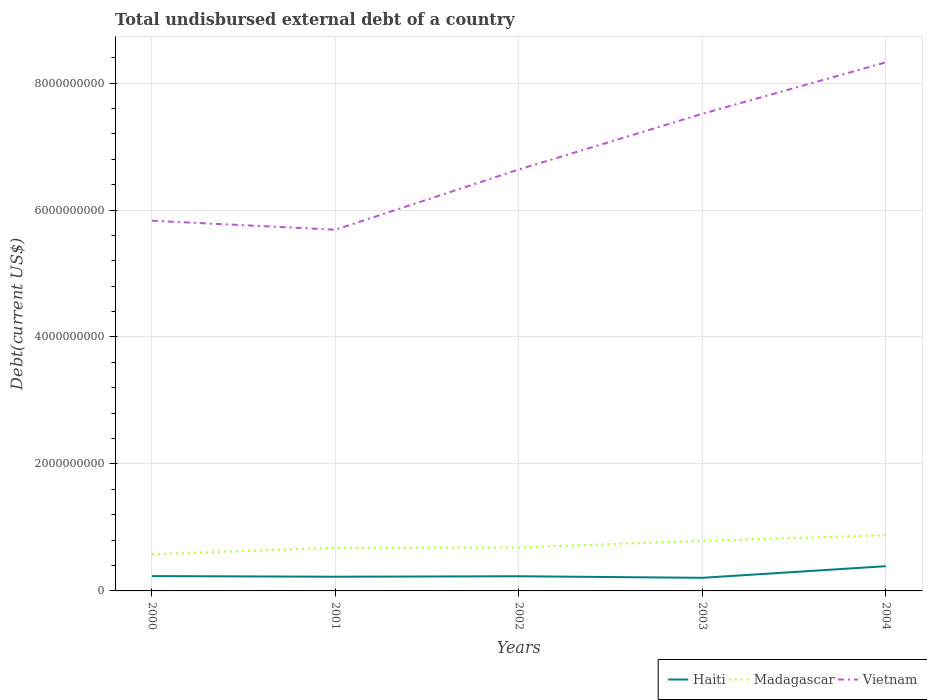Does the line corresponding to Haiti intersect with the line corresponding to Madagascar?
Your answer should be compact. No. Is the number of lines equal to the number of legend labels?
Make the answer very short. Yes. Across all years, what is the maximum total undisbursed external debt in Madagascar?
Your answer should be compact. 5.77e+08. In which year was the total undisbursed external debt in Haiti maximum?
Make the answer very short. 2003. What is the total total undisbursed external debt in Vietnam in the graph?
Offer a very short reply. -1.83e+09. What is the difference between the highest and the second highest total undisbursed external debt in Vietnam?
Ensure brevity in your answer.  2.64e+09. How many lines are there?
Give a very brief answer. 3. How many years are there in the graph?
Provide a short and direct response. 5. Does the graph contain any zero values?
Your response must be concise. No. Does the graph contain grids?
Provide a short and direct response. Yes. Where does the legend appear in the graph?
Give a very brief answer. Bottom right. How many legend labels are there?
Keep it short and to the point. 3. How are the legend labels stacked?
Provide a succinct answer. Horizontal. What is the title of the graph?
Ensure brevity in your answer.  Total undisbursed external debt of a country. What is the label or title of the Y-axis?
Offer a terse response. Debt(current US$). What is the Debt(current US$) of Haiti in 2000?
Keep it short and to the point. 2.34e+08. What is the Debt(current US$) of Madagascar in 2000?
Your response must be concise. 5.77e+08. What is the Debt(current US$) of Vietnam in 2000?
Ensure brevity in your answer.  5.83e+09. What is the Debt(current US$) in Haiti in 2001?
Make the answer very short. 2.24e+08. What is the Debt(current US$) of Madagascar in 2001?
Provide a short and direct response. 6.79e+08. What is the Debt(current US$) of Vietnam in 2001?
Offer a terse response. 5.69e+09. What is the Debt(current US$) in Haiti in 2002?
Keep it short and to the point. 2.31e+08. What is the Debt(current US$) of Madagascar in 2002?
Your answer should be very brief. 6.84e+08. What is the Debt(current US$) of Vietnam in 2002?
Provide a succinct answer. 6.64e+09. What is the Debt(current US$) in Haiti in 2003?
Your answer should be compact. 2.06e+08. What is the Debt(current US$) of Madagascar in 2003?
Give a very brief answer. 7.90e+08. What is the Debt(current US$) of Vietnam in 2003?
Your answer should be very brief. 7.52e+09. What is the Debt(current US$) of Haiti in 2004?
Ensure brevity in your answer.  3.90e+08. What is the Debt(current US$) in Madagascar in 2004?
Offer a terse response. 8.78e+08. What is the Debt(current US$) of Vietnam in 2004?
Your answer should be compact. 8.33e+09. Across all years, what is the maximum Debt(current US$) of Haiti?
Offer a very short reply. 3.90e+08. Across all years, what is the maximum Debt(current US$) in Madagascar?
Make the answer very short. 8.78e+08. Across all years, what is the maximum Debt(current US$) of Vietnam?
Your response must be concise. 8.33e+09. Across all years, what is the minimum Debt(current US$) of Haiti?
Keep it short and to the point. 2.06e+08. Across all years, what is the minimum Debt(current US$) in Madagascar?
Offer a very short reply. 5.77e+08. Across all years, what is the minimum Debt(current US$) in Vietnam?
Your answer should be very brief. 5.69e+09. What is the total Debt(current US$) of Haiti in the graph?
Provide a succinct answer. 1.28e+09. What is the total Debt(current US$) in Madagascar in the graph?
Your response must be concise. 3.61e+09. What is the total Debt(current US$) in Vietnam in the graph?
Ensure brevity in your answer.  3.40e+1. What is the difference between the Debt(current US$) of Haiti in 2000 and that in 2001?
Offer a very short reply. 9.94e+06. What is the difference between the Debt(current US$) in Madagascar in 2000 and that in 2001?
Provide a short and direct response. -1.02e+08. What is the difference between the Debt(current US$) in Vietnam in 2000 and that in 2001?
Offer a terse response. 1.42e+08. What is the difference between the Debt(current US$) of Haiti in 2000 and that in 2002?
Ensure brevity in your answer.  2.86e+06. What is the difference between the Debt(current US$) in Madagascar in 2000 and that in 2002?
Ensure brevity in your answer.  -1.07e+08. What is the difference between the Debt(current US$) in Vietnam in 2000 and that in 2002?
Provide a short and direct response. -8.07e+08. What is the difference between the Debt(current US$) of Haiti in 2000 and that in 2003?
Offer a very short reply. 2.72e+07. What is the difference between the Debt(current US$) in Madagascar in 2000 and that in 2003?
Keep it short and to the point. -2.13e+08. What is the difference between the Debt(current US$) in Vietnam in 2000 and that in 2003?
Your answer should be very brief. -1.68e+09. What is the difference between the Debt(current US$) of Haiti in 2000 and that in 2004?
Make the answer very short. -1.56e+08. What is the difference between the Debt(current US$) of Madagascar in 2000 and that in 2004?
Make the answer very short. -3.00e+08. What is the difference between the Debt(current US$) of Vietnam in 2000 and that in 2004?
Ensure brevity in your answer.  -2.49e+09. What is the difference between the Debt(current US$) of Haiti in 2001 and that in 2002?
Ensure brevity in your answer.  -7.08e+06. What is the difference between the Debt(current US$) of Madagascar in 2001 and that in 2002?
Your answer should be very brief. -5.17e+06. What is the difference between the Debt(current US$) in Vietnam in 2001 and that in 2002?
Provide a succinct answer. -9.49e+08. What is the difference between the Debt(current US$) in Haiti in 2001 and that in 2003?
Give a very brief answer. 1.72e+07. What is the difference between the Debt(current US$) in Madagascar in 2001 and that in 2003?
Make the answer very short. -1.10e+08. What is the difference between the Debt(current US$) in Vietnam in 2001 and that in 2003?
Offer a very short reply. -1.83e+09. What is the difference between the Debt(current US$) of Haiti in 2001 and that in 2004?
Your answer should be compact. -1.66e+08. What is the difference between the Debt(current US$) in Madagascar in 2001 and that in 2004?
Keep it short and to the point. -1.98e+08. What is the difference between the Debt(current US$) in Vietnam in 2001 and that in 2004?
Provide a short and direct response. -2.64e+09. What is the difference between the Debt(current US$) in Haiti in 2002 and that in 2003?
Make the answer very short. 2.43e+07. What is the difference between the Debt(current US$) of Madagascar in 2002 and that in 2003?
Provide a succinct answer. -1.05e+08. What is the difference between the Debt(current US$) in Vietnam in 2002 and that in 2003?
Offer a terse response. -8.77e+08. What is the difference between the Debt(current US$) of Haiti in 2002 and that in 2004?
Give a very brief answer. -1.59e+08. What is the difference between the Debt(current US$) of Madagascar in 2002 and that in 2004?
Provide a short and direct response. -1.93e+08. What is the difference between the Debt(current US$) of Vietnam in 2002 and that in 2004?
Your response must be concise. -1.69e+09. What is the difference between the Debt(current US$) of Haiti in 2003 and that in 2004?
Keep it short and to the point. -1.83e+08. What is the difference between the Debt(current US$) of Madagascar in 2003 and that in 2004?
Your answer should be compact. -8.78e+07. What is the difference between the Debt(current US$) in Vietnam in 2003 and that in 2004?
Your answer should be compact. -8.11e+08. What is the difference between the Debt(current US$) in Haiti in 2000 and the Debt(current US$) in Madagascar in 2001?
Provide a short and direct response. -4.46e+08. What is the difference between the Debt(current US$) of Haiti in 2000 and the Debt(current US$) of Vietnam in 2001?
Keep it short and to the point. -5.46e+09. What is the difference between the Debt(current US$) of Madagascar in 2000 and the Debt(current US$) of Vietnam in 2001?
Offer a terse response. -5.11e+09. What is the difference between the Debt(current US$) in Haiti in 2000 and the Debt(current US$) in Madagascar in 2002?
Give a very brief answer. -4.51e+08. What is the difference between the Debt(current US$) of Haiti in 2000 and the Debt(current US$) of Vietnam in 2002?
Provide a short and direct response. -6.41e+09. What is the difference between the Debt(current US$) of Madagascar in 2000 and the Debt(current US$) of Vietnam in 2002?
Provide a succinct answer. -6.06e+09. What is the difference between the Debt(current US$) in Haiti in 2000 and the Debt(current US$) in Madagascar in 2003?
Keep it short and to the point. -5.56e+08. What is the difference between the Debt(current US$) in Haiti in 2000 and the Debt(current US$) in Vietnam in 2003?
Ensure brevity in your answer.  -7.28e+09. What is the difference between the Debt(current US$) of Madagascar in 2000 and the Debt(current US$) of Vietnam in 2003?
Your answer should be compact. -6.94e+09. What is the difference between the Debt(current US$) in Haiti in 2000 and the Debt(current US$) in Madagascar in 2004?
Make the answer very short. -6.44e+08. What is the difference between the Debt(current US$) in Haiti in 2000 and the Debt(current US$) in Vietnam in 2004?
Your response must be concise. -8.09e+09. What is the difference between the Debt(current US$) in Madagascar in 2000 and the Debt(current US$) in Vietnam in 2004?
Make the answer very short. -7.75e+09. What is the difference between the Debt(current US$) in Haiti in 2001 and the Debt(current US$) in Madagascar in 2002?
Ensure brevity in your answer.  -4.61e+08. What is the difference between the Debt(current US$) of Haiti in 2001 and the Debt(current US$) of Vietnam in 2002?
Offer a very short reply. -6.42e+09. What is the difference between the Debt(current US$) of Madagascar in 2001 and the Debt(current US$) of Vietnam in 2002?
Give a very brief answer. -5.96e+09. What is the difference between the Debt(current US$) in Haiti in 2001 and the Debt(current US$) in Madagascar in 2003?
Provide a succinct answer. -5.66e+08. What is the difference between the Debt(current US$) in Haiti in 2001 and the Debt(current US$) in Vietnam in 2003?
Ensure brevity in your answer.  -7.29e+09. What is the difference between the Debt(current US$) in Madagascar in 2001 and the Debt(current US$) in Vietnam in 2003?
Your response must be concise. -6.84e+09. What is the difference between the Debt(current US$) of Haiti in 2001 and the Debt(current US$) of Madagascar in 2004?
Give a very brief answer. -6.54e+08. What is the difference between the Debt(current US$) of Haiti in 2001 and the Debt(current US$) of Vietnam in 2004?
Make the answer very short. -8.10e+09. What is the difference between the Debt(current US$) of Madagascar in 2001 and the Debt(current US$) of Vietnam in 2004?
Provide a succinct answer. -7.65e+09. What is the difference between the Debt(current US$) of Haiti in 2002 and the Debt(current US$) of Madagascar in 2003?
Give a very brief answer. -5.59e+08. What is the difference between the Debt(current US$) of Haiti in 2002 and the Debt(current US$) of Vietnam in 2003?
Offer a terse response. -7.28e+09. What is the difference between the Debt(current US$) in Madagascar in 2002 and the Debt(current US$) in Vietnam in 2003?
Keep it short and to the point. -6.83e+09. What is the difference between the Debt(current US$) in Haiti in 2002 and the Debt(current US$) in Madagascar in 2004?
Provide a short and direct response. -6.47e+08. What is the difference between the Debt(current US$) of Haiti in 2002 and the Debt(current US$) of Vietnam in 2004?
Provide a succinct answer. -8.10e+09. What is the difference between the Debt(current US$) in Madagascar in 2002 and the Debt(current US$) in Vietnam in 2004?
Keep it short and to the point. -7.64e+09. What is the difference between the Debt(current US$) in Haiti in 2003 and the Debt(current US$) in Madagascar in 2004?
Keep it short and to the point. -6.71e+08. What is the difference between the Debt(current US$) in Haiti in 2003 and the Debt(current US$) in Vietnam in 2004?
Offer a terse response. -8.12e+09. What is the difference between the Debt(current US$) of Madagascar in 2003 and the Debt(current US$) of Vietnam in 2004?
Offer a very short reply. -7.54e+09. What is the average Debt(current US$) in Haiti per year?
Your answer should be compact. 2.57e+08. What is the average Debt(current US$) in Madagascar per year?
Your answer should be very brief. 7.22e+08. What is the average Debt(current US$) of Vietnam per year?
Offer a very short reply. 6.80e+09. In the year 2000, what is the difference between the Debt(current US$) in Haiti and Debt(current US$) in Madagascar?
Your answer should be very brief. -3.43e+08. In the year 2000, what is the difference between the Debt(current US$) in Haiti and Debt(current US$) in Vietnam?
Make the answer very short. -5.60e+09. In the year 2000, what is the difference between the Debt(current US$) of Madagascar and Debt(current US$) of Vietnam?
Ensure brevity in your answer.  -5.25e+09. In the year 2001, what is the difference between the Debt(current US$) in Haiti and Debt(current US$) in Madagascar?
Give a very brief answer. -4.56e+08. In the year 2001, what is the difference between the Debt(current US$) of Haiti and Debt(current US$) of Vietnam?
Offer a terse response. -5.47e+09. In the year 2001, what is the difference between the Debt(current US$) of Madagascar and Debt(current US$) of Vietnam?
Your answer should be very brief. -5.01e+09. In the year 2002, what is the difference between the Debt(current US$) of Haiti and Debt(current US$) of Madagascar?
Offer a terse response. -4.54e+08. In the year 2002, what is the difference between the Debt(current US$) of Haiti and Debt(current US$) of Vietnam?
Keep it short and to the point. -6.41e+09. In the year 2002, what is the difference between the Debt(current US$) in Madagascar and Debt(current US$) in Vietnam?
Provide a short and direct response. -5.95e+09. In the year 2003, what is the difference between the Debt(current US$) in Haiti and Debt(current US$) in Madagascar?
Your answer should be compact. -5.83e+08. In the year 2003, what is the difference between the Debt(current US$) in Haiti and Debt(current US$) in Vietnam?
Ensure brevity in your answer.  -7.31e+09. In the year 2003, what is the difference between the Debt(current US$) in Madagascar and Debt(current US$) in Vietnam?
Your answer should be very brief. -6.73e+09. In the year 2004, what is the difference between the Debt(current US$) of Haiti and Debt(current US$) of Madagascar?
Your answer should be very brief. -4.88e+08. In the year 2004, what is the difference between the Debt(current US$) in Haiti and Debt(current US$) in Vietnam?
Make the answer very short. -7.94e+09. In the year 2004, what is the difference between the Debt(current US$) in Madagascar and Debt(current US$) in Vietnam?
Give a very brief answer. -7.45e+09. What is the ratio of the Debt(current US$) of Haiti in 2000 to that in 2001?
Give a very brief answer. 1.04. What is the ratio of the Debt(current US$) in Madagascar in 2000 to that in 2001?
Keep it short and to the point. 0.85. What is the ratio of the Debt(current US$) in Vietnam in 2000 to that in 2001?
Offer a terse response. 1.02. What is the ratio of the Debt(current US$) in Haiti in 2000 to that in 2002?
Provide a succinct answer. 1.01. What is the ratio of the Debt(current US$) of Madagascar in 2000 to that in 2002?
Offer a terse response. 0.84. What is the ratio of the Debt(current US$) in Vietnam in 2000 to that in 2002?
Offer a very short reply. 0.88. What is the ratio of the Debt(current US$) in Haiti in 2000 to that in 2003?
Keep it short and to the point. 1.13. What is the ratio of the Debt(current US$) of Madagascar in 2000 to that in 2003?
Offer a terse response. 0.73. What is the ratio of the Debt(current US$) of Vietnam in 2000 to that in 2003?
Provide a succinct answer. 0.78. What is the ratio of the Debt(current US$) in Haiti in 2000 to that in 2004?
Make the answer very short. 0.6. What is the ratio of the Debt(current US$) in Madagascar in 2000 to that in 2004?
Offer a very short reply. 0.66. What is the ratio of the Debt(current US$) of Vietnam in 2000 to that in 2004?
Offer a very short reply. 0.7. What is the ratio of the Debt(current US$) in Haiti in 2001 to that in 2002?
Make the answer very short. 0.97. What is the ratio of the Debt(current US$) of Vietnam in 2001 to that in 2002?
Ensure brevity in your answer.  0.86. What is the ratio of the Debt(current US$) of Haiti in 2001 to that in 2003?
Offer a terse response. 1.08. What is the ratio of the Debt(current US$) of Madagascar in 2001 to that in 2003?
Make the answer very short. 0.86. What is the ratio of the Debt(current US$) in Vietnam in 2001 to that in 2003?
Make the answer very short. 0.76. What is the ratio of the Debt(current US$) in Haiti in 2001 to that in 2004?
Give a very brief answer. 0.57. What is the ratio of the Debt(current US$) in Madagascar in 2001 to that in 2004?
Your answer should be compact. 0.77. What is the ratio of the Debt(current US$) of Vietnam in 2001 to that in 2004?
Your answer should be compact. 0.68. What is the ratio of the Debt(current US$) of Haiti in 2002 to that in 2003?
Offer a very short reply. 1.12. What is the ratio of the Debt(current US$) in Madagascar in 2002 to that in 2003?
Your answer should be compact. 0.87. What is the ratio of the Debt(current US$) in Vietnam in 2002 to that in 2003?
Offer a very short reply. 0.88. What is the ratio of the Debt(current US$) of Haiti in 2002 to that in 2004?
Provide a succinct answer. 0.59. What is the ratio of the Debt(current US$) in Madagascar in 2002 to that in 2004?
Keep it short and to the point. 0.78. What is the ratio of the Debt(current US$) of Vietnam in 2002 to that in 2004?
Give a very brief answer. 0.8. What is the ratio of the Debt(current US$) in Haiti in 2003 to that in 2004?
Offer a very short reply. 0.53. What is the ratio of the Debt(current US$) of Madagascar in 2003 to that in 2004?
Your answer should be compact. 0.9. What is the ratio of the Debt(current US$) in Vietnam in 2003 to that in 2004?
Keep it short and to the point. 0.9. What is the difference between the highest and the second highest Debt(current US$) in Haiti?
Your response must be concise. 1.56e+08. What is the difference between the highest and the second highest Debt(current US$) of Madagascar?
Provide a succinct answer. 8.78e+07. What is the difference between the highest and the second highest Debt(current US$) of Vietnam?
Your response must be concise. 8.11e+08. What is the difference between the highest and the lowest Debt(current US$) in Haiti?
Your answer should be compact. 1.83e+08. What is the difference between the highest and the lowest Debt(current US$) of Madagascar?
Keep it short and to the point. 3.00e+08. What is the difference between the highest and the lowest Debt(current US$) of Vietnam?
Keep it short and to the point. 2.64e+09. 